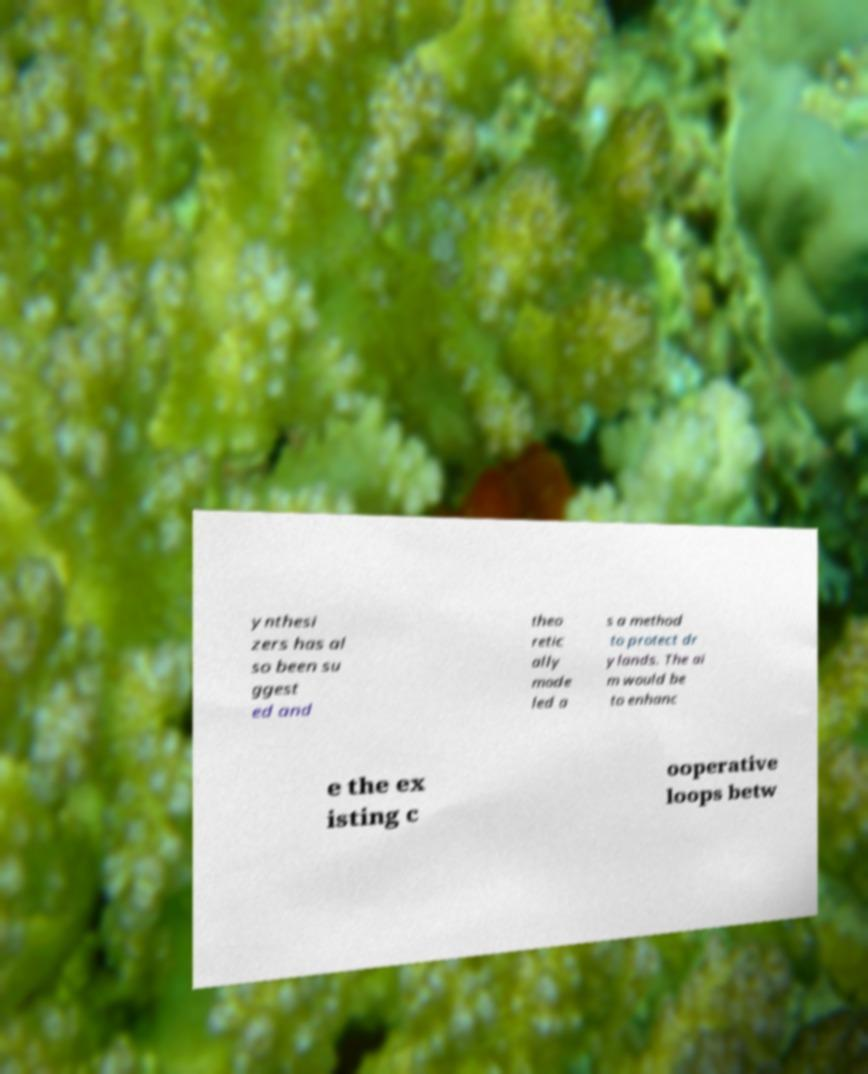Please read and relay the text visible in this image. What does it say? ynthesi zers has al so been su ggest ed and theo retic ally mode led a s a method to protect dr ylands. The ai m would be to enhanc e the ex isting c ooperative loops betw 